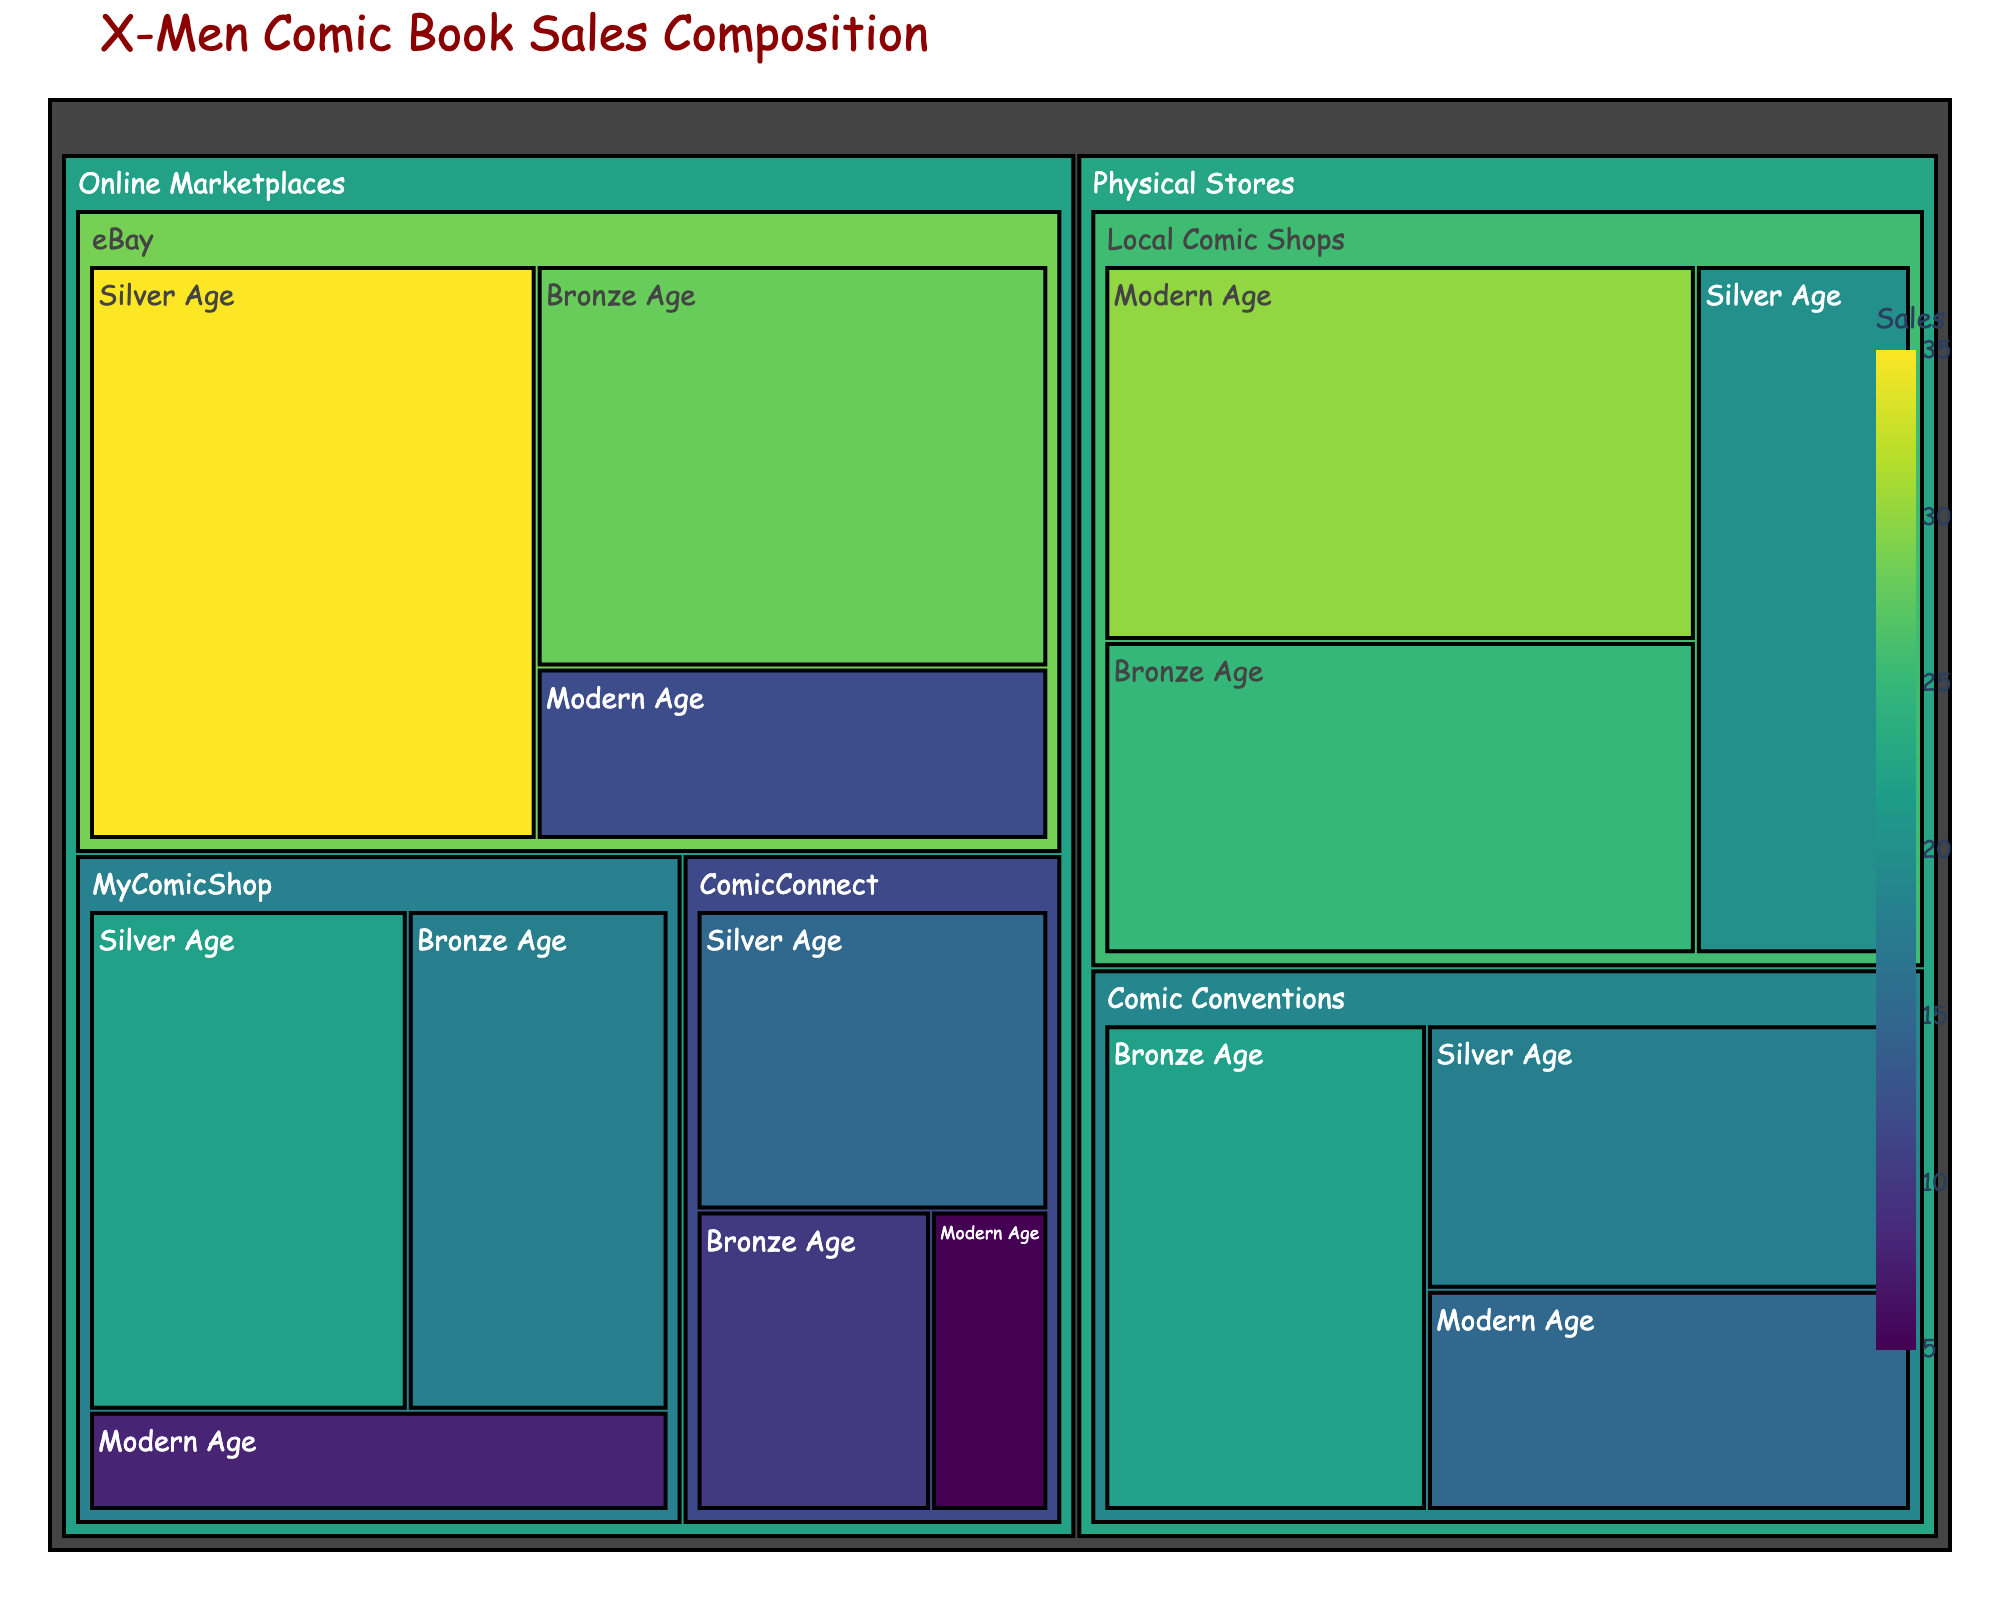What is the title of the treemap? The title of the figure is usually displayed prominently at the top of the plot. In this case, it is provided in the code.
Answer: X-Men Comic Book Sales Composition How many categories are under 'Online Marketplaces'? The treemap shows different categories for each platform. The 'Online Marketplaces' section breaks down into three categories based on the marketplace.
Answer: 3 Which category has the highest sales in 'Physical Stores'? Both stores and conventions fall under 'Physical Stores.' By comparing sales values within each subcategory, we determine which has the highest sale.
Answer: Local Comic Shops, Modern Age What is the total sales of Silver Age comics across all platforms? Summing up the sales values of Silver Age comics from both 'Online Marketplaces' and 'Physical Stores.'
Answer: 110 Are total Modern Age sales higher than Bronze Age sales? By summing up the sales for each age category and then comparing: Modern Age is (12 + 8 + 5 + 30 + 15 = 70) and Bronze Age is (28 + 18 + 10 + 25 + 22 = 103).
Answer: No Which subcategory under 'eBay' has the lowest sales? Comparing the sales figures of each subcategory under 'eBay.'
Answer: Modern Age Which has a higher Bronze Age sales, Comic Conventions or Local Comic Shops? Comparing the sales values of Bronze Age comics between Comic Conventions and Local Comic Shops in the 'Physical Stores' category.
Answer: Local Comic Shops How do sales at Comic Conventions for Silver Age compare with MyComicShop for the same age? Comparing the sales value of Silver Age comics between Comic Conventions and MyComicShop.
Answer: Higher at Comic Conventions What's the average sales across Modern Age comics at Online Marketplaces? Calculating the average by summing up sales and then dividing by the number of subcategories. (12 + 8 + 5) / 3 = 25 / 3.
Answer: 8.33 